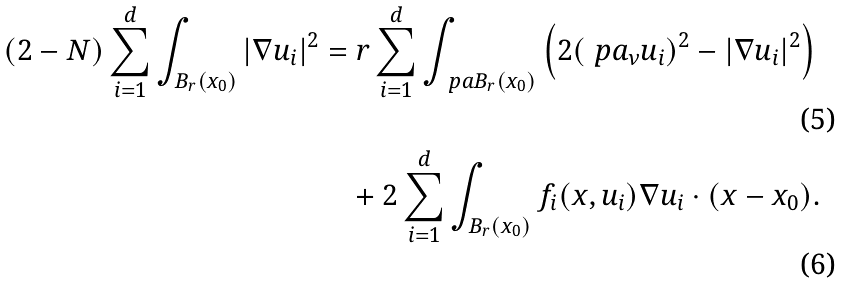Convert formula to latex. <formula><loc_0><loc_0><loc_500><loc_500>( 2 - N ) \sum _ { i = 1 } ^ { d } \int _ { B _ { r } ( x _ { 0 } ) } | \nabla u _ { i } | ^ { 2 } & = r \sum _ { i = 1 } ^ { d } \int _ { \ p a B _ { r } ( x _ { 0 } ) } \left ( 2 ( \ p a _ { \nu } u _ { i } ) ^ { 2 } - | \nabla u _ { i } | ^ { 2 } \right ) \\ & \quad + 2 \sum _ { i = 1 } ^ { d } \int _ { B _ { r } ( x _ { 0 } ) } f _ { i } ( x , u _ { i } ) \nabla u _ { i } \cdot ( x - x _ { 0 } ) .</formula> 